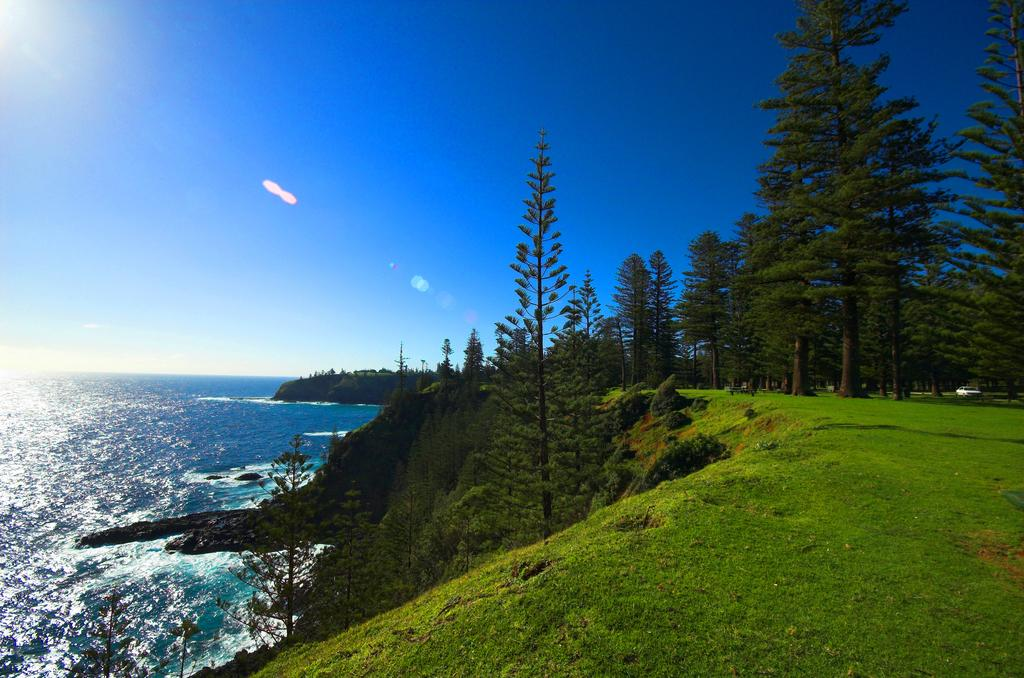What can be seen on the left side of the image? There is water on the left side of the image. What is located in the center of the image? There are trees in the center of the image. What type of vegetation is at the bottom of the image? There is grass at the bottom of the image. What is visible in the background of the image? The sky is visible in the background of the image. What type of vest is the governor wearing in the image? There is no governor or vest present in the image. What achievements has the achiever accomplished in the image? There is no achiever or achievements depicted in the image. 